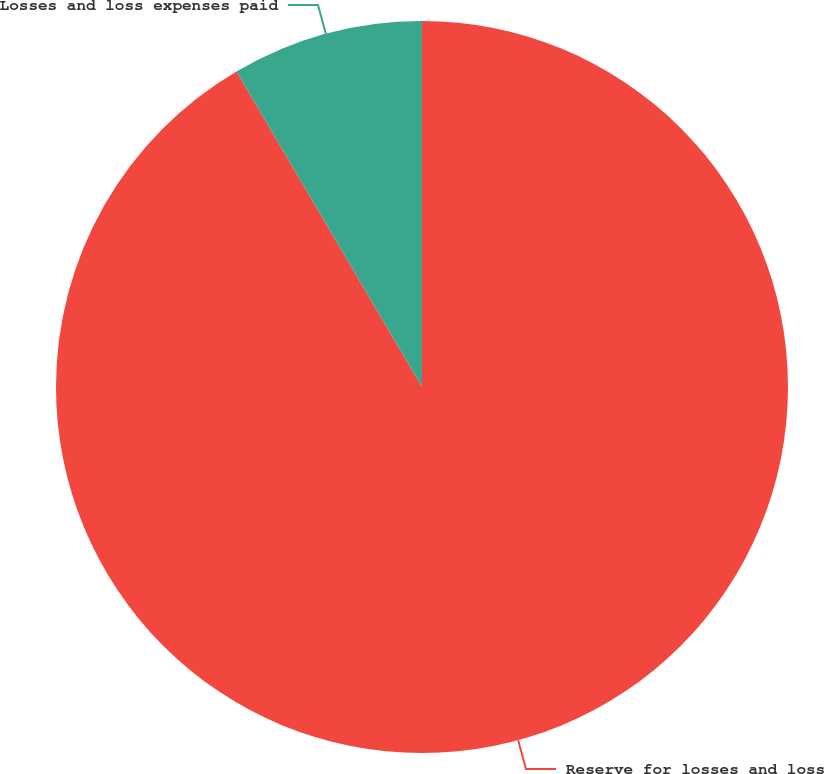<chart> <loc_0><loc_0><loc_500><loc_500><pie_chart><fcel>Reserve for losses and loss<fcel>Losses and loss expenses paid<nl><fcel>91.54%<fcel>8.46%<nl></chart> 